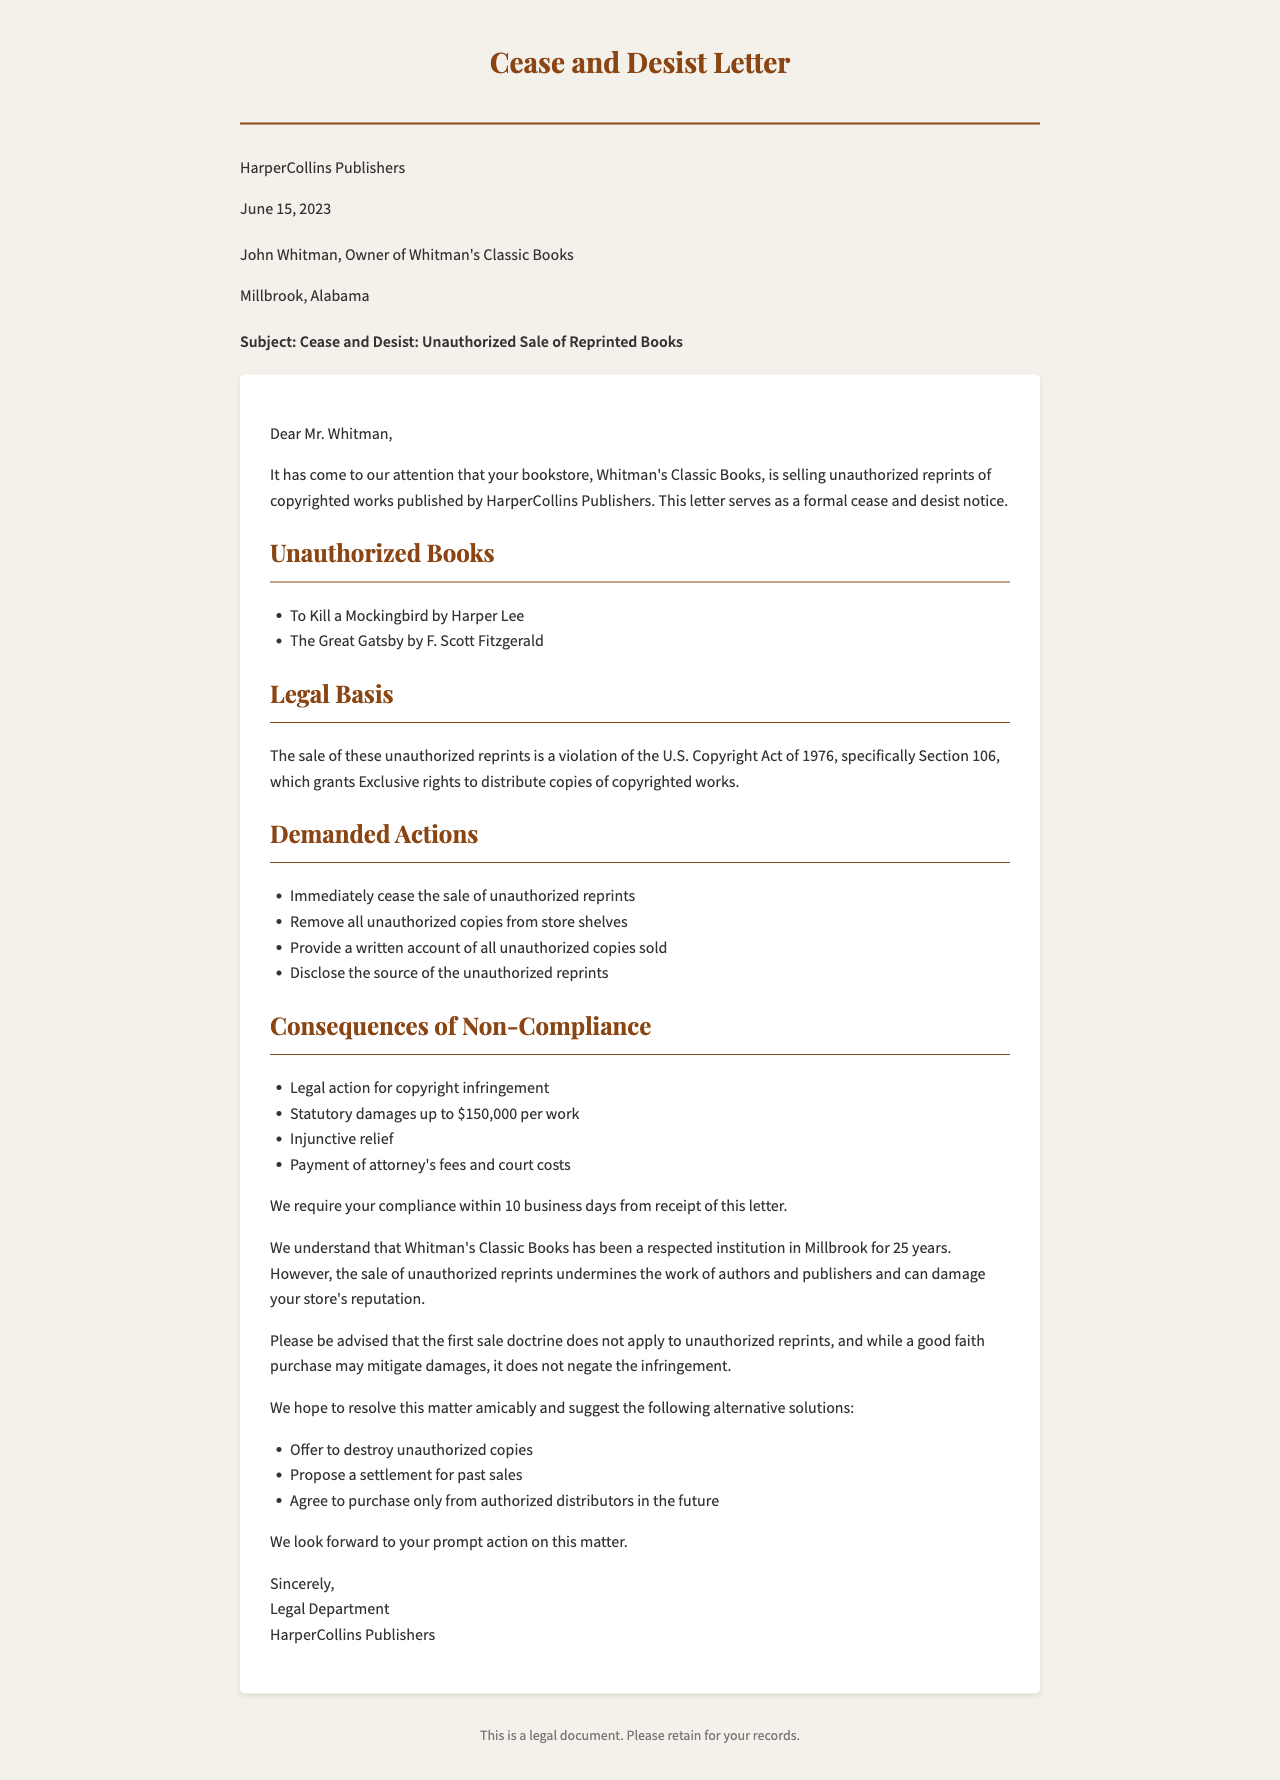What is the date of the letter? The date is specified in the letter details section of the document.
Answer: June 15, 2023 Who is the recipient of the letter? The recipient's name is mentioned at the beginning of the letter.
Answer: John Whitman What are the unauthorized books listed in the letter? The letter provides a list of the unauthorized books in a specific section.
Answer: To Kill a Mockingbird, The Great Gatsby What is the compliance deadline mentioned in the letter? The compliance deadline is specified towards the end of the document.
Answer: 10 business days from receipt of this letter What legal basis is cited for the cease and desist demand? The letter indicates the legal basis under copyright law for the demanded actions.
Answer: U.S. Copyright Act of 1976, Section 106 What are the consequences of non-compliance according to the letter? The letter lists the potential consequences in a specific section.
Answer: Legal action for copyright infringement, Statutory damages up to $150,000 per work, Injunctive relief, Payment of attorney's fees and court costs What action is required for resolution suggested in the alternatives? The letter discusses alternative solutions which can aid in resolving the issues.
Answer: Offer to destroy unauthorized copies What is the primary purpose of this document? The document serves a specific legal purpose as indicated in its title and content.
Answer: Cease and desist notice 